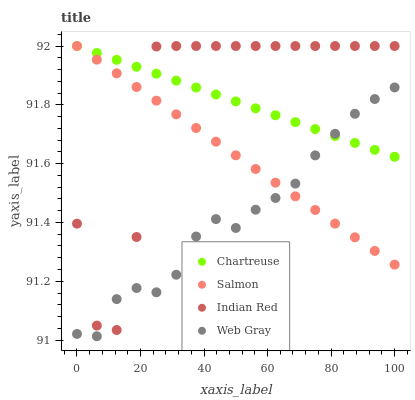Does Web Gray have the minimum area under the curve?
Answer yes or no. Yes. Does Indian Red have the maximum area under the curve?
Answer yes or no. Yes. Does Salmon have the minimum area under the curve?
Answer yes or no. No. Does Salmon have the maximum area under the curve?
Answer yes or no. No. Is Chartreuse the smoothest?
Answer yes or no. Yes. Is Indian Red the roughest?
Answer yes or no. Yes. Is Web Gray the smoothest?
Answer yes or no. No. Is Web Gray the roughest?
Answer yes or no. No. Does Web Gray have the lowest value?
Answer yes or no. Yes. Does Salmon have the lowest value?
Answer yes or no. No. Does Indian Red have the highest value?
Answer yes or no. Yes. Does Web Gray have the highest value?
Answer yes or no. No. Does Indian Red intersect Salmon?
Answer yes or no. Yes. Is Indian Red less than Salmon?
Answer yes or no. No. Is Indian Red greater than Salmon?
Answer yes or no. No. 